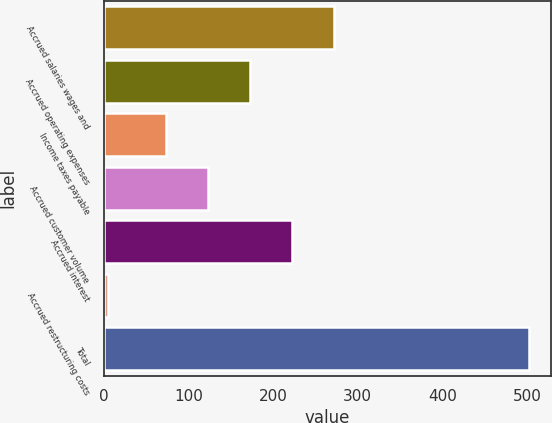<chart> <loc_0><loc_0><loc_500><loc_500><bar_chart><fcel>Accrued salaries wages and<fcel>Accrued operating expenses<fcel>Income taxes payable<fcel>Accrued customer volume<fcel>Accrued interest<fcel>Accrued restructuring costs<fcel>Total<nl><fcel>272.56<fcel>172.98<fcel>73.4<fcel>123.19<fcel>222.77<fcel>5<fcel>502.9<nl></chart> 